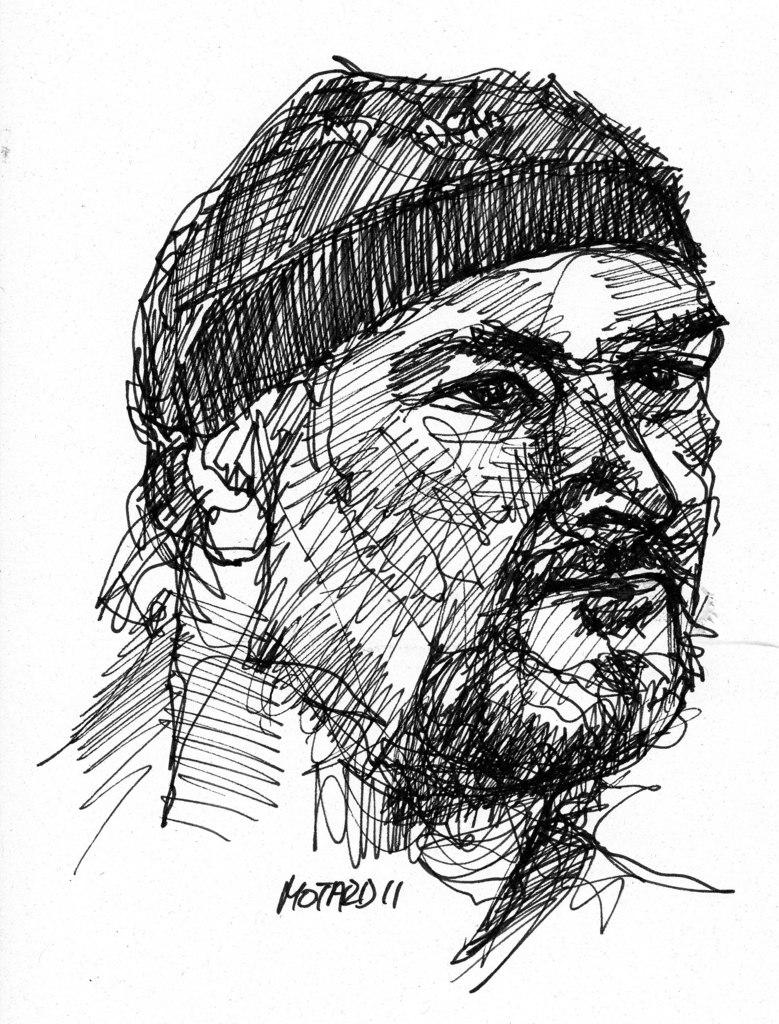What is depicted in the image? There is a sketch art of a man in the image. Can you describe the subject of the sketch? The sketch art features a man. Where can the man be seen buying fruits in the image? There is no reference to a man buying fruits or a market in the image; it only features a sketch art of a man. 